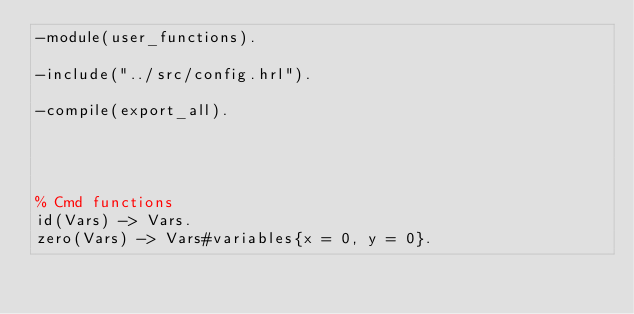Convert code to text. <code><loc_0><loc_0><loc_500><loc_500><_Erlang_>-module(user_functions).

-include("../src/config.hrl").

-compile(export_all).




% Cmd functions
id(Vars) -> Vars.
zero(Vars) -> Vars#variables{x = 0, y = 0}.</code> 